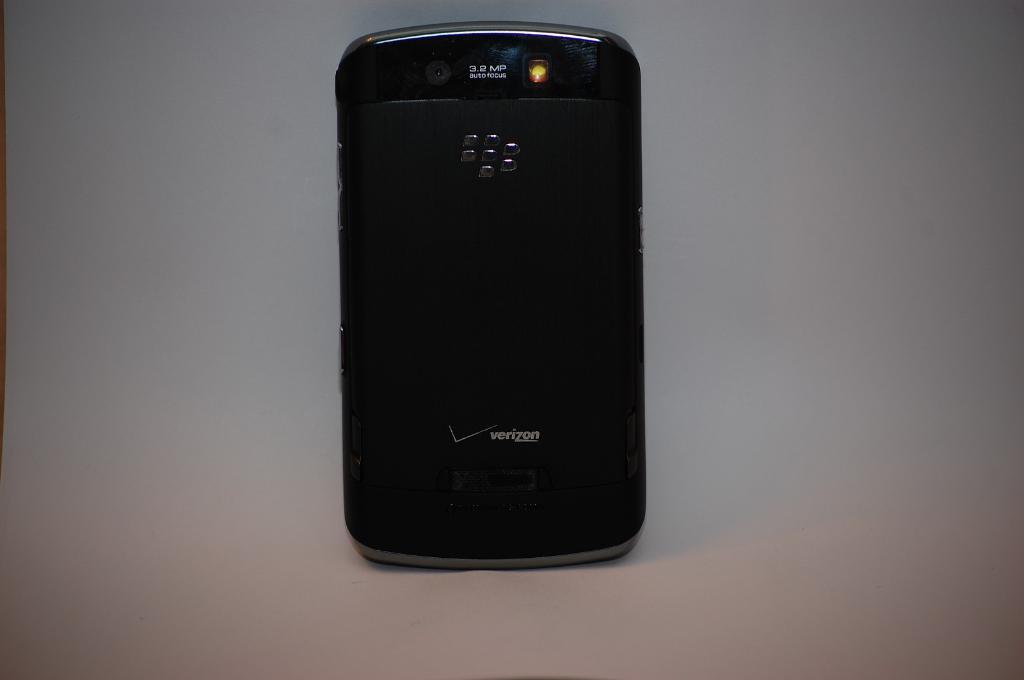What carrier is the phone from?
Offer a terse response. Verizon. How many megapixels are in this cellphone camera?
Provide a succinct answer. 3.2. 